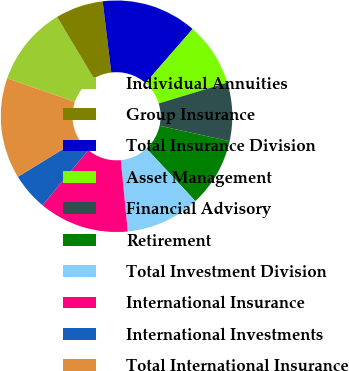Convert chart to OTSL. <chart><loc_0><loc_0><loc_500><loc_500><pie_chart><fcel>Individual Annuities<fcel>Group Insurance<fcel>Total Insurance Division<fcel>Asset Management<fcel>Financial Advisory<fcel>Retirement<fcel>Total Investment Division<fcel>International Insurance<fcel>International Investments<fcel>Total International Insurance<nl><fcel>11.11%<fcel>6.67%<fcel>13.33%<fcel>8.89%<fcel>8.15%<fcel>9.63%<fcel>10.37%<fcel>12.59%<fcel>5.19%<fcel>14.07%<nl></chart> 